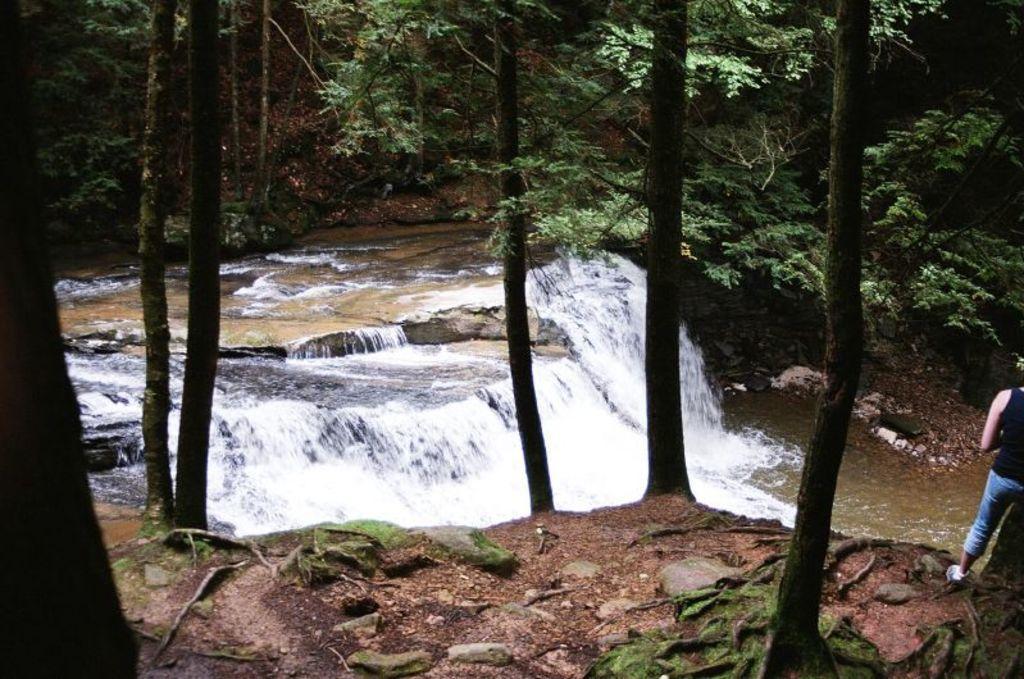Describe this image in one or two sentences. In this picture I can see water. I can see trees. I can see a person standing on the right side. 